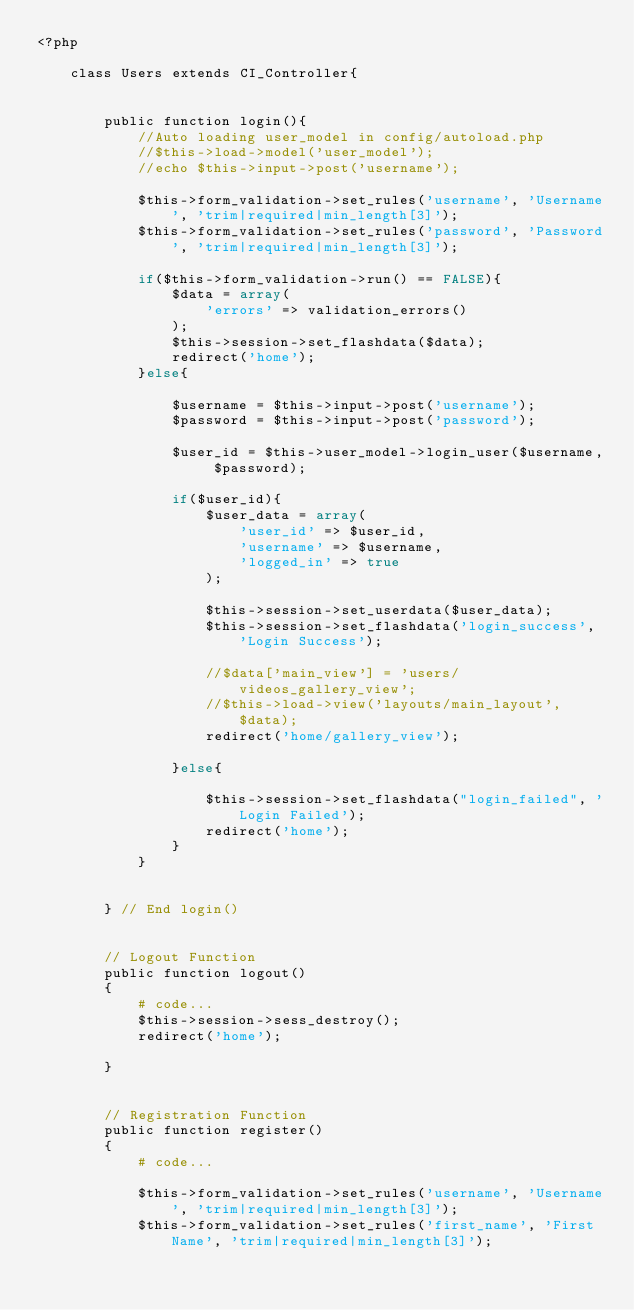Convert code to text. <code><loc_0><loc_0><loc_500><loc_500><_PHP_><?php 

    class Users extends CI_Controller{
        
        
        public function login(){
            //Auto loading user_model in config/autoload.php
            //$this->load->model('user_model');
            //echo $this->input->post('username');

            $this->form_validation->set_rules('username', 'Username', 'trim|required|min_length[3]');
            $this->form_validation->set_rules('password', 'Password', 'trim|required|min_length[3]');

            if($this->form_validation->run() == FALSE){
                $data = array(
                    'errors' => validation_errors() 
                );
                $this->session->set_flashdata($data);
                redirect('home');
            }else{

                $username = $this->input->post('username');
                $password = $this->input->post('password');

                $user_id = $this->user_model->login_user($username, $password);

                if($user_id){
                    $user_data = array(
                        'user_id' => $user_id,
                        'username' => $username,
                        'logged_in' => true
                    );

                    $this->session->set_userdata($user_data);
                    $this->session->set_flashdata('login_success', 'Login Success');

                    //$data['main_view'] = 'users/videos_gallery_view';
                    //$this->load->view('layouts/main_layout', $data);
                    redirect('home/gallery_view');
                    
                }else{
                   
                    $this->session->set_flashdata("login_failed", 'Login Failed');
                    redirect('home');
                }
            }

           
        } // End login()
    

        // Logout Function
        public function logout()
        {
            # code...
            $this->session->sess_destroy();
            redirect('home');

        }


        // Registration Function
        public function register()
        {
            # code...
            
            $this->form_validation->set_rules('username', 'Username', 'trim|required|min_length[3]');
            $this->form_validation->set_rules('first_name', 'First Name', 'trim|required|min_length[3]');</code> 